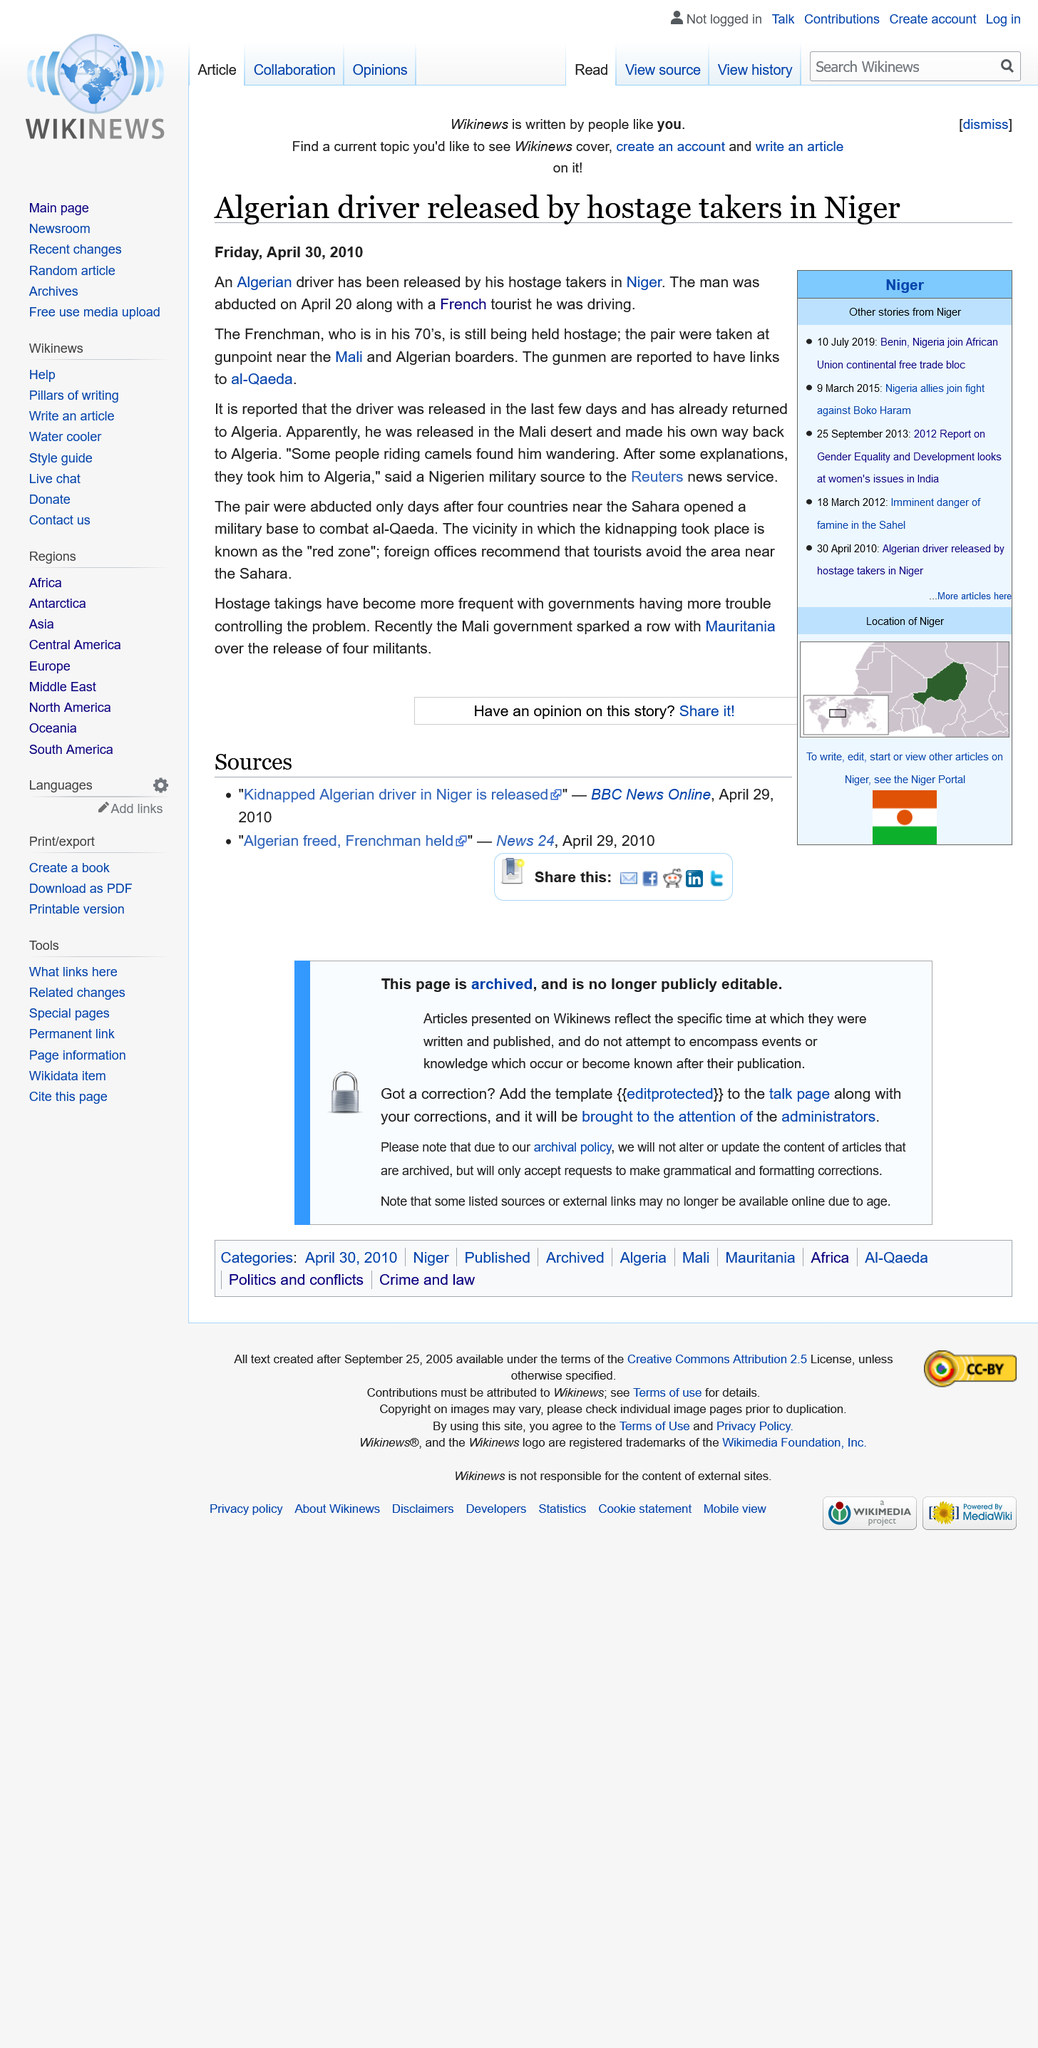Point out several critical features in this image. It is not true that all of the hostages have been freed. Only the Algerian driver was released, and the Frenchman is still being held hostage. The abduction took place in Niger. On April 20th 2010, a man was abducted along with a tourist that he was driving. 